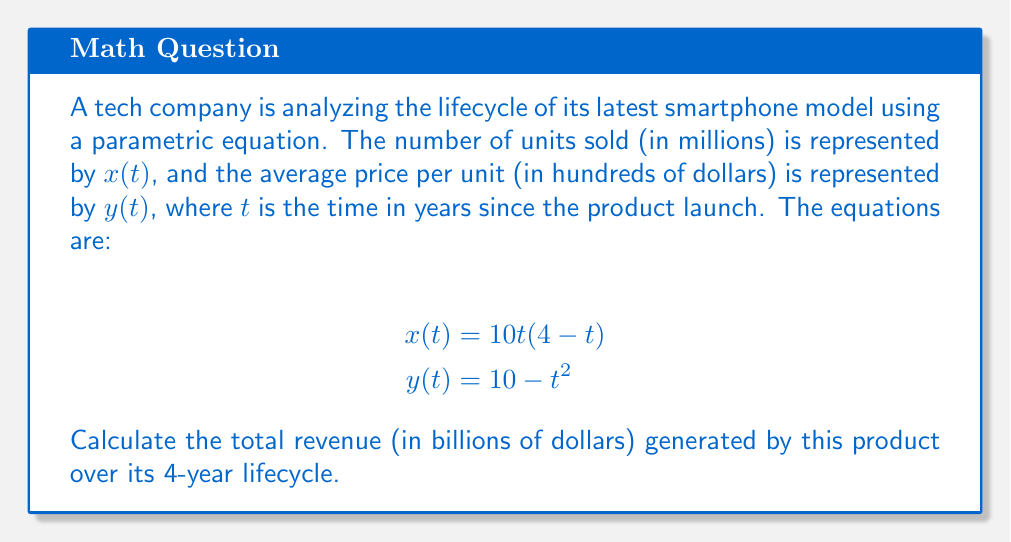What is the answer to this math problem? To solve this problem, we'll follow these steps:

1) The revenue at any given time $t$ is the product of units sold and price per unit. We need to integrate this over the 4-year period.

2) Revenue function:
   $R(t) = x(t) \cdot y(t) \cdot 0.1$
   (We multiply by 0.1 to convert the units to billions of dollars)

3) Substituting the given equations:
   $R(t) = [10t(4-t)] \cdot [10 - t^2] \cdot 0.1$

4) Expanding this:
   $R(t) = (40t - 10t^2) \cdot (10 - t^2) \cdot 0.1$
   $R(t) = (400t - 100t^2 - 40t^3 + 10t^4) \cdot 0.1$

5) To get the total revenue, we integrate this function from $t=0$ to $t=4$:

   $$\text{Total Revenue} = \int_0^4 R(t) dt = 0.1 \int_0^4 (400t - 100t^2 - 40t^3 + 10t^4) dt$$

6) Integrating:
   $$0.1 \left[ 200t^2 - \frac{100}{3}t^3 - 10t^4 + 2t^5 \right]_0^4$$

7) Evaluating at the limits:
   $$0.1 \left[ (3200 - 533.33 - 2560 + 512) - (0 - 0 - 0 + 0) \right]$$
   $$0.1 \cdot 618.67 = 61.867$$

Therefore, the total revenue over the 4-year lifecycle is approximately 61.867 billion dollars.
Answer: $61.867 billion 